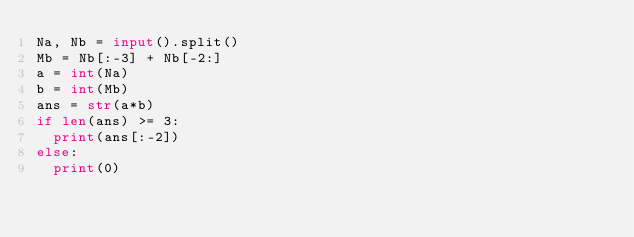Convert code to text. <code><loc_0><loc_0><loc_500><loc_500><_Python_>Na, Nb = input().split()
Mb = Nb[:-3] + Nb[-2:]
a = int(Na)
b = int(Mb)
ans = str(a*b)
if len(ans) >= 3:
  print(ans[:-2])
else:
  print(0)</code> 